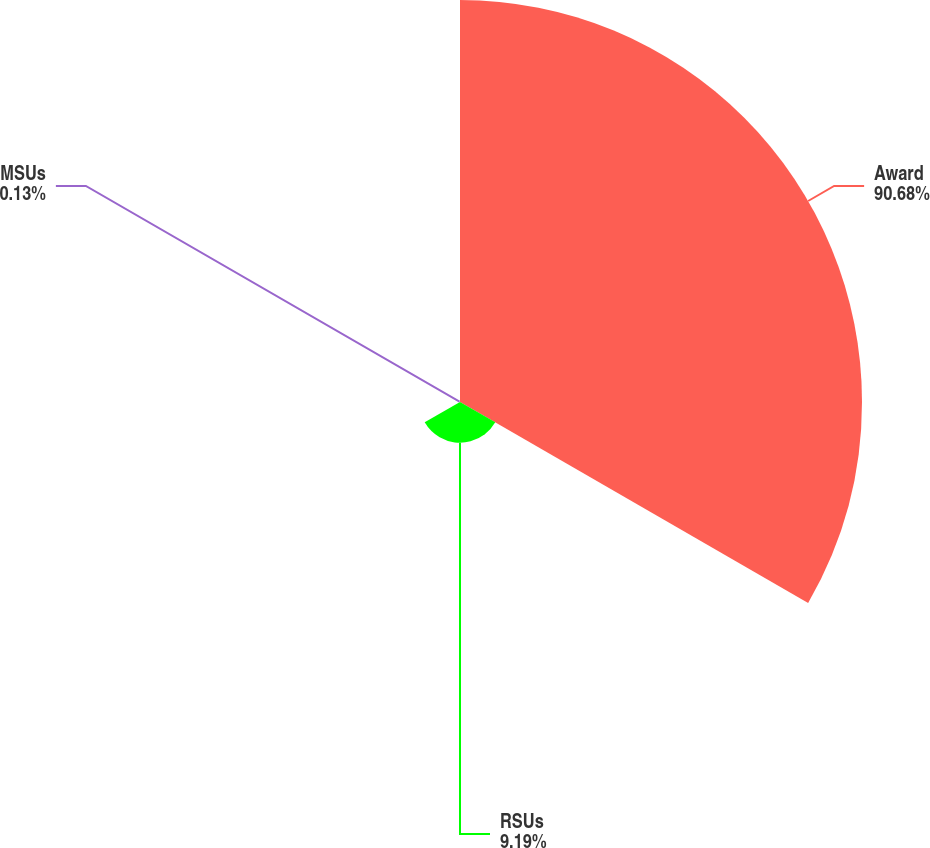Convert chart to OTSL. <chart><loc_0><loc_0><loc_500><loc_500><pie_chart><fcel>Award<fcel>RSUs<fcel>MSUs<nl><fcel>90.68%<fcel>9.19%<fcel>0.13%<nl></chart> 